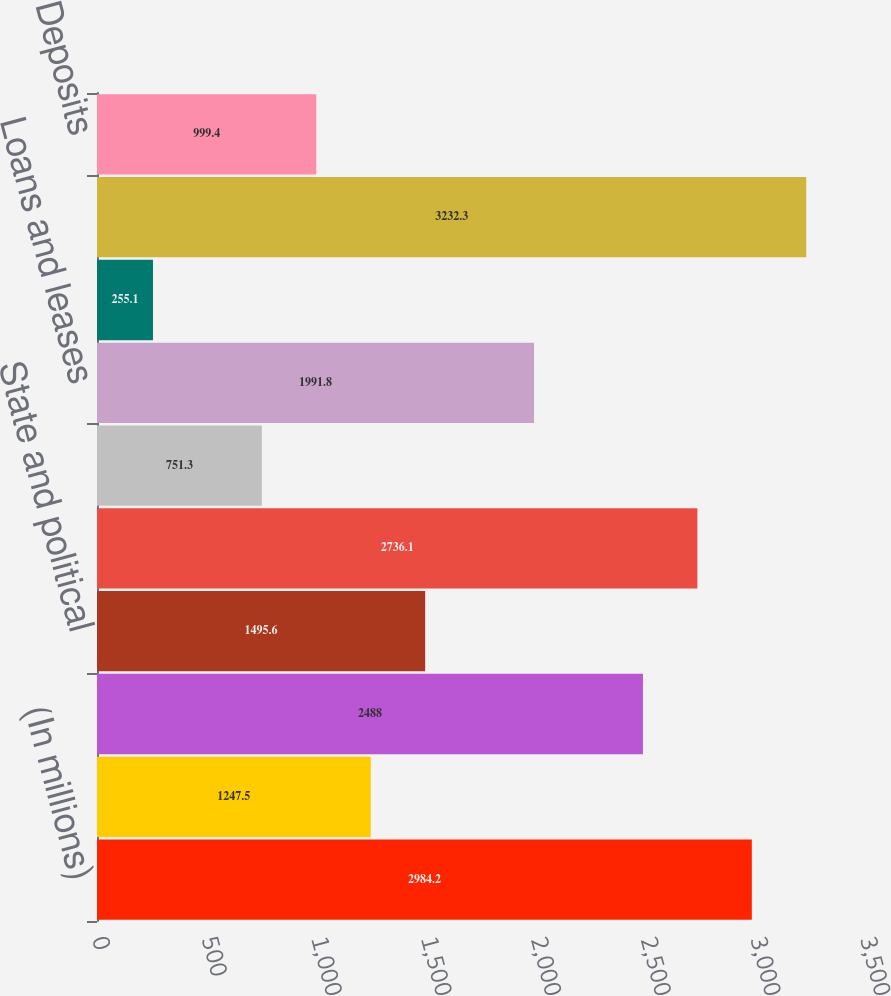<chart> <loc_0><loc_0><loc_500><loc_500><bar_chart><fcel>(In millions)<fcel>Deposits with banks<fcel>US Treasury and federal<fcel>State and political<fcel>Other investments<fcel>Securities purchased under<fcel>Loans and leases<fcel>Other interest-earning assets<fcel>Total interest income<fcel>Deposits<nl><fcel>2984.2<fcel>1247.5<fcel>2488<fcel>1495.6<fcel>2736.1<fcel>751.3<fcel>1991.8<fcel>255.1<fcel>3232.3<fcel>999.4<nl></chart> 